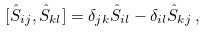Convert formula to latex. <formula><loc_0><loc_0><loc_500><loc_500>[ \hat { S } _ { i j } , \hat { S } _ { k l } ] = \delta _ { j k } \hat { S } _ { i l } - \delta _ { i l } \hat { S } _ { k j } \, ,</formula> 